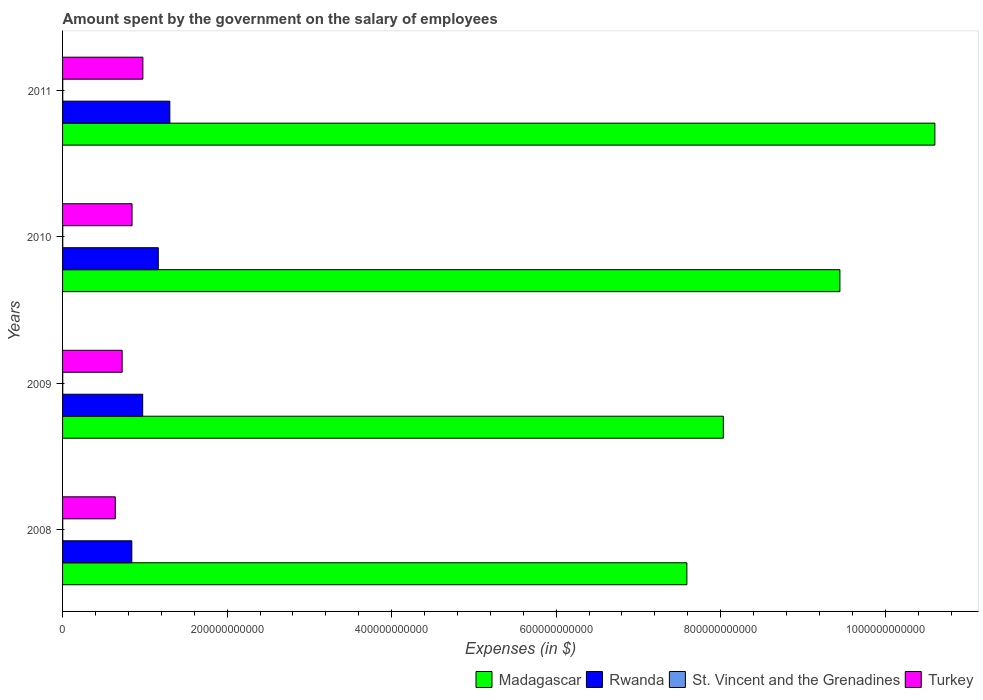How many groups of bars are there?
Ensure brevity in your answer.  4. Are the number of bars per tick equal to the number of legend labels?
Provide a succinct answer. Yes. Are the number of bars on each tick of the Y-axis equal?
Make the answer very short. Yes. How many bars are there on the 2nd tick from the bottom?
Provide a short and direct response. 4. In how many cases, is the number of bars for a given year not equal to the number of legend labels?
Keep it short and to the point. 0. What is the amount spent on the salary of employees by the government in St. Vincent and the Grenadines in 2011?
Ensure brevity in your answer.  2.31e+08. Across all years, what is the maximum amount spent on the salary of employees by the government in Turkey?
Give a very brief answer. 9.76e+1. Across all years, what is the minimum amount spent on the salary of employees by the government in Madagascar?
Keep it short and to the point. 7.59e+11. In which year was the amount spent on the salary of employees by the government in Turkey maximum?
Offer a very short reply. 2011. What is the total amount spent on the salary of employees by the government in Madagascar in the graph?
Give a very brief answer. 3.57e+12. What is the difference between the amount spent on the salary of employees by the government in Rwanda in 2008 and that in 2011?
Ensure brevity in your answer.  -4.62e+1. What is the difference between the amount spent on the salary of employees by the government in Madagascar in 2010 and the amount spent on the salary of employees by the government in Turkey in 2011?
Your answer should be compact. 8.47e+11. What is the average amount spent on the salary of employees by the government in Madagascar per year?
Your response must be concise. 8.92e+11. In the year 2008, what is the difference between the amount spent on the salary of employees by the government in St. Vincent and the Grenadines and amount spent on the salary of employees by the government in Rwanda?
Your response must be concise. -8.40e+1. What is the ratio of the amount spent on the salary of employees by the government in Turkey in 2008 to that in 2009?
Provide a short and direct response. 0.88. What is the difference between the highest and the second highest amount spent on the salary of employees by the government in Madagascar?
Offer a very short reply. 1.15e+11. What is the difference between the highest and the lowest amount spent on the salary of employees by the government in St. Vincent and the Grenadines?
Your answer should be very brief. 2.44e+07. In how many years, is the amount spent on the salary of employees by the government in St. Vincent and the Grenadines greater than the average amount spent on the salary of employees by the government in St. Vincent and the Grenadines taken over all years?
Provide a short and direct response. 2. Is the sum of the amount spent on the salary of employees by the government in St. Vincent and the Grenadines in 2009 and 2011 greater than the maximum amount spent on the salary of employees by the government in Rwanda across all years?
Your answer should be very brief. No. What does the 1st bar from the bottom in 2011 represents?
Your answer should be compact. Madagascar. Is it the case that in every year, the sum of the amount spent on the salary of employees by the government in Turkey and amount spent on the salary of employees by the government in Rwanda is greater than the amount spent on the salary of employees by the government in St. Vincent and the Grenadines?
Ensure brevity in your answer.  Yes. How many bars are there?
Offer a terse response. 16. What is the difference between two consecutive major ticks on the X-axis?
Make the answer very short. 2.00e+11. Are the values on the major ticks of X-axis written in scientific E-notation?
Your answer should be very brief. No. How many legend labels are there?
Ensure brevity in your answer.  4. What is the title of the graph?
Ensure brevity in your answer.  Amount spent by the government on the salary of employees. What is the label or title of the X-axis?
Your answer should be very brief. Expenses (in $). What is the label or title of the Y-axis?
Offer a very short reply. Years. What is the Expenses (in $) of Madagascar in 2008?
Ensure brevity in your answer.  7.59e+11. What is the Expenses (in $) of Rwanda in 2008?
Keep it short and to the point. 8.42e+1. What is the Expenses (in $) of St. Vincent and the Grenadines in 2008?
Ensure brevity in your answer.  2.07e+08. What is the Expenses (in $) of Turkey in 2008?
Provide a succinct answer. 6.41e+1. What is the Expenses (in $) of Madagascar in 2009?
Your answer should be very brief. 8.03e+11. What is the Expenses (in $) in Rwanda in 2009?
Ensure brevity in your answer.  9.74e+1. What is the Expenses (in $) of St. Vincent and the Grenadines in 2009?
Make the answer very short. 2.12e+08. What is the Expenses (in $) in Turkey in 2009?
Your response must be concise. 7.24e+1. What is the Expenses (in $) of Madagascar in 2010?
Provide a succinct answer. 9.45e+11. What is the Expenses (in $) of Rwanda in 2010?
Give a very brief answer. 1.16e+11. What is the Expenses (in $) in St. Vincent and the Grenadines in 2010?
Your response must be concise. 2.22e+08. What is the Expenses (in $) in Turkey in 2010?
Provide a succinct answer. 8.45e+1. What is the Expenses (in $) of Madagascar in 2011?
Provide a succinct answer. 1.06e+12. What is the Expenses (in $) of Rwanda in 2011?
Provide a short and direct response. 1.30e+11. What is the Expenses (in $) in St. Vincent and the Grenadines in 2011?
Make the answer very short. 2.31e+08. What is the Expenses (in $) in Turkey in 2011?
Ensure brevity in your answer.  9.76e+1. Across all years, what is the maximum Expenses (in $) of Madagascar?
Your answer should be compact. 1.06e+12. Across all years, what is the maximum Expenses (in $) in Rwanda?
Your answer should be very brief. 1.30e+11. Across all years, what is the maximum Expenses (in $) of St. Vincent and the Grenadines?
Offer a very short reply. 2.31e+08. Across all years, what is the maximum Expenses (in $) in Turkey?
Offer a very short reply. 9.76e+1. Across all years, what is the minimum Expenses (in $) of Madagascar?
Offer a terse response. 7.59e+11. Across all years, what is the minimum Expenses (in $) of Rwanda?
Offer a very short reply. 8.42e+1. Across all years, what is the minimum Expenses (in $) of St. Vincent and the Grenadines?
Offer a terse response. 2.07e+08. Across all years, what is the minimum Expenses (in $) of Turkey?
Offer a terse response. 6.41e+1. What is the total Expenses (in $) of Madagascar in the graph?
Provide a succinct answer. 3.57e+12. What is the total Expenses (in $) in Rwanda in the graph?
Keep it short and to the point. 4.28e+11. What is the total Expenses (in $) in St. Vincent and the Grenadines in the graph?
Ensure brevity in your answer.  8.72e+08. What is the total Expenses (in $) of Turkey in the graph?
Keep it short and to the point. 3.19e+11. What is the difference between the Expenses (in $) of Madagascar in 2008 and that in 2009?
Your answer should be very brief. -4.43e+1. What is the difference between the Expenses (in $) in Rwanda in 2008 and that in 2009?
Your answer should be compact. -1.32e+1. What is the difference between the Expenses (in $) of St. Vincent and the Grenadines in 2008 and that in 2009?
Provide a short and direct response. -5.20e+06. What is the difference between the Expenses (in $) in Turkey in 2008 and that in 2009?
Offer a very short reply. -8.34e+09. What is the difference between the Expenses (in $) in Madagascar in 2008 and that in 2010?
Give a very brief answer. -1.86e+11. What is the difference between the Expenses (in $) in Rwanda in 2008 and that in 2010?
Offer a very short reply. -3.22e+1. What is the difference between the Expenses (in $) in St. Vincent and the Grenadines in 2008 and that in 2010?
Provide a short and direct response. -1.50e+07. What is the difference between the Expenses (in $) in Turkey in 2008 and that in 2010?
Make the answer very short. -2.04e+1. What is the difference between the Expenses (in $) in Madagascar in 2008 and that in 2011?
Make the answer very short. -3.01e+11. What is the difference between the Expenses (in $) of Rwanda in 2008 and that in 2011?
Offer a terse response. -4.62e+1. What is the difference between the Expenses (in $) in St. Vincent and the Grenadines in 2008 and that in 2011?
Offer a terse response. -2.44e+07. What is the difference between the Expenses (in $) in Turkey in 2008 and that in 2011?
Give a very brief answer. -3.35e+1. What is the difference between the Expenses (in $) in Madagascar in 2009 and that in 2010?
Make the answer very short. -1.42e+11. What is the difference between the Expenses (in $) of Rwanda in 2009 and that in 2010?
Your answer should be very brief. -1.90e+1. What is the difference between the Expenses (in $) of St. Vincent and the Grenadines in 2009 and that in 2010?
Give a very brief answer. -9.80e+06. What is the difference between the Expenses (in $) in Turkey in 2009 and that in 2010?
Ensure brevity in your answer.  -1.20e+1. What is the difference between the Expenses (in $) of Madagascar in 2009 and that in 2011?
Give a very brief answer. -2.57e+11. What is the difference between the Expenses (in $) in Rwanda in 2009 and that in 2011?
Offer a very short reply. -3.30e+1. What is the difference between the Expenses (in $) of St. Vincent and the Grenadines in 2009 and that in 2011?
Provide a short and direct response. -1.92e+07. What is the difference between the Expenses (in $) in Turkey in 2009 and that in 2011?
Make the answer very short. -2.52e+1. What is the difference between the Expenses (in $) of Madagascar in 2010 and that in 2011?
Keep it short and to the point. -1.15e+11. What is the difference between the Expenses (in $) of Rwanda in 2010 and that in 2011?
Your answer should be compact. -1.40e+1. What is the difference between the Expenses (in $) of St. Vincent and the Grenadines in 2010 and that in 2011?
Provide a succinct answer. -9.40e+06. What is the difference between the Expenses (in $) in Turkey in 2010 and that in 2011?
Your response must be concise. -1.32e+1. What is the difference between the Expenses (in $) of Madagascar in 2008 and the Expenses (in $) of Rwanda in 2009?
Offer a terse response. 6.61e+11. What is the difference between the Expenses (in $) of Madagascar in 2008 and the Expenses (in $) of St. Vincent and the Grenadines in 2009?
Make the answer very short. 7.59e+11. What is the difference between the Expenses (in $) of Madagascar in 2008 and the Expenses (in $) of Turkey in 2009?
Provide a succinct answer. 6.86e+11. What is the difference between the Expenses (in $) of Rwanda in 2008 and the Expenses (in $) of St. Vincent and the Grenadines in 2009?
Provide a short and direct response. 8.40e+1. What is the difference between the Expenses (in $) in Rwanda in 2008 and the Expenses (in $) in Turkey in 2009?
Make the answer very short. 1.18e+1. What is the difference between the Expenses (in $) of St. Vincent and the Grenadines in 2008 and the Expenses (in $) of Turkey in 2009?
Your response must be concise. -7.22e+1. What is the difference between the Expenses (in $) of Madagascar in 2008 and the Expenses (in $) of Rwanda in 2010?
Offer a terse response. 6.43e+11. What is the difference between the Expenses (in $) in Madagascar in 2008 and the Expenses (in $) in St. Vincent and the Grenadines in 2010?
Offer a terse response. 7.59e+11. What is the difference between the Expenses (in $) in Madagascar in 2008 and the Expenses (in $) in Turkey in 2010?
Provide a succinct answer. 6.74e+11. What is the difference between the Expenses (in $) of Rwanda in 2008 and the Expenses (in $) of St. Vincent and the Grenadines in 2010?
Make the answer very short. 8.40e+1. What is the difference between the Expenses (in $) of Rwanda in 2008 and the Expenses (in $) of Turkey in 2010?
Keep it short and to the point. -2.87e+08. What is the difference between the Expenses (in $) of St. Vincent and the Grenadines in 2008 and the Expenses (in $) of Turkey in 2010?
Ensure brevity in your answer.  -8.43e+1. What is the difference between the Expenses (in $) in Madagascar in 2008 and the Expenses (in $) in Rwanda in 2011?
Keep it short and to the point. 6.29e+11. What is the difference between the Expenses (in $) of Madagascar in 2008 and the Expenses (in $) of St. Vincent and the Grenadines in 2011?
Give a very brief answer. 7.59e+11. What is the difference between the Expenses (in $) of Madagascar in 2008 and the Expenses (in $) of Turkey in 2011?
Offer a terse response. 6.61e+11. What is the difference between the Expenses (in $) of Rwanda in 2008 and the Expenses (in $) of St. Vincent and the Grenadines in 2011?
Give a very brief answer. 8.39e+1. What is the difference between the Expenses (in $) in Rwanda in 2008 and the Expenses (in $) in Turkey in 2011?
Offer a terse response. -1.34e+1. What is the difference between the Expenses (in $) in St. Vincent and the Grenadines in 2008 and the Expenses (in $) in Turkey in 2011?
Give a very brief answer. -9.74e+1. What is the difference between the Expenses (in $) of Madagascar in 2009 and the Expenses (in $) of Rwanda in 2010?
Make the answer very short. 6.87e+11. What is the difference between the Expenses (in $) in Madagascar in 2009 and the Expenses (in $) in St. Vincent and the Grenadines in 2010?
Keep it short and to the point. 8.03e+11. What is the difference between the Expenses (in $) of Madagascar in 2009 and the Expenses (in $) of Turkey in 2010?
Keep it short and to the point. 7.19e+11. What is the difference between the Expenses (in $) of Rwanda in 2009 and the Expenses (in $) of St. Vincent and the Grenadines in 2010?
Make the answer very short. 9.72e+1. What is the difference between the Expenses (in $) of Rwanda in 2009 and the Expenses (in $) of Turkey in 2010?
Make the answer very short. 1.29e+1. What is the difference between the Expenses (in $) of St. Vincent and the Grenadines in 2009 and the Expenses (in $) of Turkey in 2010?
Provide a succinct answer. -8.43e+1. What is the difference between the Expenses (in $) in Madagascar in 2009 and the Expenses (in $) in Rwanda in 2011?
Your answer should be compact. 6.73e+11. What is the difference between the Expenses (in $) of Madagascar in 2009 and the Expenses (in $) of St. Vincent and the Grenadines in 2011?
Your answer should be very brief. 8.03e+11. What is the difference between the Expenses (in $) of Madagascar in 2009 and the Expenses (in $) of Turkey in 2011?
Offer a very short reply. 7.06e+11. What is the difference between the Expenses (in $) of Rwanda in 2009 and the Expenses (in $) of St. Vincent and the Grenadines in 2011?
Provide a short and direct response. 9.72e+1. What is the difference between the Expenses (in $) of Rwanda in 2009 and the Expenses (in $) of Turkey in 2011?
Your response must be concise. -2.25e+08. What is the difference between the Expenses (in $) of St. Vincent and the Grenadines in 2009 and the Expenses (in $) of Turkey in 2011?
Your answer should be compact. -9.74e+1. What is the difference between the Expenses (in $) of Madagascar in 2010 and the Expenses (in $) of Rwanda in 2011?
Offer a very short reply. 8.15e+11. What is the difference between the Expenses (in $) of Madagascar in 2010 and the Expenses (in $) of St. Vincent and the Grenadines in 2011?
Make the answer very short. 9.45e+11. What is the difference between the Expenses (in $) of Madagascar in 2010 and the Expenses (in $) of Turkey in 2011?
Keep it short and to the point. 8.47e+11. What is the difference between the Expenses (in $) of Rwanda in 2010 and the Expenses (in $) of St. Vincent and the Grenadines in 2011?
Make the answer very short. 1.16e+11. What is the difference between the Expenses (in $) in Rwanda in 2010 and the Expenses (in $) in Turkey in 2011?
Offer a terse response. 1.87e+1. What is the difference between the Expenses (in $) of St. Vincent and the Grenadines in 2010 and the Expenses (in $) of Turkey in 2011?
Keep it short and to the point. -9.74e+1. What is the average Expenses (in $) in Madagascar per year?
Keep it short and to the point. 8.92e+11. What is the average Expenses (in $) in Rwanda per year?
Keep it short and to the point. 1.07e+11. What is the average Expenses (in $) of St. Vincent and the Grenadines per year?
Your response must be concise. 2.18e+08. What is the average Expenses (in $) in Turkey per year?
Your response must be concise. 7.97e+1. In the year 2008, what is the difference between the Expenses (in $) in Madagascar and Expenses (in $) in Rwanda?
Your answer should be compact. 6.75e+11. In the year 2008, what is the difference between the Expenses (in $) in Madagascar and Expenses (in $) in St. Vincent and the Grenadines?
Offer a very short reply. 7.59e+11. In the year 2008, what is the difference between the Expenses (in $) of Madagascar and Expenses (in $) of Turkey?
Make the answer very short. 6.95e+11. In the year 2008, what is the difference between the Expenses (in $) of Rwanda and Expenses (in $) of St. Vincent and the Grenadines?
Provide a short and direct response. 8.40e+1. In the year 2008, what is the difference between the Expenses (in $) of Rwanda and Expenses (in $) of Turkey?
Ensure brevity in your answer.  2.01e+1. In the year 2008, what is the difference between the Expenses (in $) in St. Vincent and the Grenadines and Expenses (in $) in Turkey?
Keep it short and to the point. -6.39e+1. In the year 2009, what is the difference between the Expenses (in $) of Madagascar and Expenses (in $) of Rwanda?
Your answer should be compact. 7.06e+11. In the year 2009, what is the difference between the Expenses (in $) of Madagascar and Expenses (in $) of St. Vincent and the Grenadines?
Your response must be concise. 8.03e+11. In the year 2009, what is the difference between the Expenses (in $) of Madagascar and Expenses (in $) of Turkey?
Offer a terse response. 7.31e+11. In the year 2009, what is the difference between the Expenses (in $) of Rwanda and Expenses (in $) of St. Vincent and the Grenadines?
Give a very brief answer. 9.72e+1. In the year 2009, what is the difference between the Expenses (in $) in Rwanda and Expenses (in $) in Turkey?
Make the answer very short. 2.50e+1. In the year 2009, what is the difference between the Expenses (in $) of St. Vincent and the Grenadines and Expenses (in $) of Turkey?
Offer a terse response. -7.22e+1. In the year 2010, what is the difference between the Expenses (in $) in Madagascar and Expenses (in $) in Rwanda?
Offer a very short reply. 8.29e+11. In the year 2010, what is the difference between the Expenses (in $) in Madagascar and Expenses (in $) in St. Vincent and the Grenadines?
Offer a terse response. 9.45e+11. In the year 2010, what is the difference between the Expenses (in $) of Madagascar and Expenses (in $) of Turkey?
Your response must be concise. 8.60e+11. In the year 2010, what is the difference between the Expenses (in $) of Rwanda and Expenses (in $) of St. Vincent and the Grenadines?
Offer a terse response. 1.16e+11. In the year 2010, what is the difference between the Expenses (in $) of Rwanda and Expenses (in $) of Turkey?
Make the answer very short. 3.19e+1. In the year 2010, what is the difference between the Expenses (in $) in St. Vincent and the Grenadines and Expenses (in $) in Turkey?
Ensure brevity in your answer.  -8.42e+1. In the year 2011, what is the difference between the Expenses (in $) in Madagascar and Expenses (in $) in Rwanda?
Make the answer very short. 9.30e+11. In the year 2011, what is the difference between the Expenses (in $) in Madagascar and Expenses (in $) in St. Vincent and the Grenadines?
Your response must be concise. 1.06e+12. In the year 2011, what is the difference between the Expenses (in $) in Madagascar and Expenses (in $) in Turkey?
Give a very brief answer. 9.63e+11. In the year 2011, what is the difference between the Expenses (in $) in Rwanda and Expenses (in $) in St. Vincent and the Grenadines?
Provide a short and direct response. 1.30e+11. In the year 2011, what is the difference between the Expenses (in $) in Rwanda and Expenses (in $) in Turkey?
Provide a short and direct response. 3.28e+1. In the year 2011, what is the difference between the Expenses (in $) in St. Vincent and the Grenadines and Expenses (in $) in Turkey?
Offer a terse response. -9.74e+1. What is the ratio of the Expenses (in $) in Madagascar in 2008 to that in 2009?
Ensure brevity in your answer.  0.94. What is the ratio of the Expenses (in $) in Rwanda in 2008 to that in 2009?
Offer a terse response. 0.86. What is the ratio of the Expenses (in $) in St. Vincent and the Grenadines in 2008 to that in 2009?
Make the answer very short. 0.98. What is the ratio of the Expenses (in $) in Turkey in 2008 to that in 2009?
Your response must be concise. 0.88. What is the ratio of the Expenses (in $) of Madagascar in 2008 to that in 2010?
Give a very brief answer. 0.8. What is the ratio of the Expenses (in $) of Rwanda in 2008 to that in 2010?
Provide a succinct answer. 0.72. What is the ratio of the Expenses (in $) of St. Vincent and the Grenadines in 2008 to that in 2010?
Your answer should be very brief. 0.93. What is the ratio of the Expenses (in $) in Turkey in 2008 to that in 2010?
Your response must be concise. 0.76. What is the ratio of the Expenses (in $) of Madagascar in 2008 to that in 2011?
Ensure brevity in your answer.  0.72. What is the ratio of the Expenses (in $) of Rwanda in 2008 to that in 2011?
Provide a succinct answer. 0.65. What is the ratio of the Expenses (in $) in St. Vincent and the Grenadines in 2008 to that in 2011?
Your response must be concise. 0.89. What is the ratio of the Expenses (in $) of Turkey in 2008 to that in 2011?
Provide a short and direct response. 0.66. What is the ratio of the Expenses (in $) of Madagascar in 2009 to that in 2010?
Your answer should be very brief. 0.85. What is the ratio of the Expenses (in $) in Rwanda in 2009 to that in 2010?
Provide a succinct answer. 0.84. What is the ratio of the Expenses (in $) in St. Vincent and the Grenadines in 2009 to that in 2010?
Your response must be concise. 0.96. What is the ratio of the Expenses (in $) in Turkey in 2009 to that in 2010?
Offer a terse response. 0.86. What is the ratio of the Expenses (in $) in Madagascar in 2009 to that in 2011?
Ensure brevity in your answer.  0.76. What is the ratio of the Expenses (in $) of Rwanda in 2009 to that in 2011?
Keep it short and to the point. 0.75. What is the ratio of the Expenses (in $) of St. Vincent and the Grenadines in 2009 to that in 2011?
Provide a short and direct response. 0.92. What is the ratio of the Expenses (in $) of Turkey in 2009 to that in 2011?
Offer a terse response. 0.74. What is the ratio of the Expenses (in $) in Madagascar in 2010 to that in 2011?
Make the answer very short. 0.89. What is the ratio of the Expenses (in $) in Rwanda in 2010 to that in 2011?
Your answer should be very brief. 0.89. What is the ratio of the Expenses (in $) in St. Vincent and the Grenadines in 2010 to that in 2011?
Your answer should be compact. 0.96. What is the ratio of the Expenses (in $) of Turkey in 2010 to that in 2011?
Give a very brief answer. 0.87. What is the difference between the highest and the second highest Expenses (in $) in Madagascar?
Make the answer very short. 1.15e+11. What is the difference between the highest and the second highest Expenses (in $) of Rwanda?
Ensure brevity in your answer.  1.40e+1. What is the difference between the highest and the second highest Expenses (in $) of St. Vincent and the Grenadines?
Offer a very short reply. 9.40e+06. What is the difference between the highest and the second highest Expenses (in $) of Turkey?
Offer a terse response. 1.32e+1. What is the difference between the highest and the lowest Expenses (in $) in Madagascar?
Offer a terse response. 3.01e+11. What is the difference between the highest and the lowest Expenses (in $) of Rwanda?
Your answer should be compact. 4.62e+1. What is the difference between the highest and the lowest Expenses (in $) in St. Vincent and the Grenadines?
Ensure brevity in your answer.  2.44e+07. What is the difference between the highest and the lowest Expenses (in $) in Turkey?
Make the answer very short. 3.35e+1. 